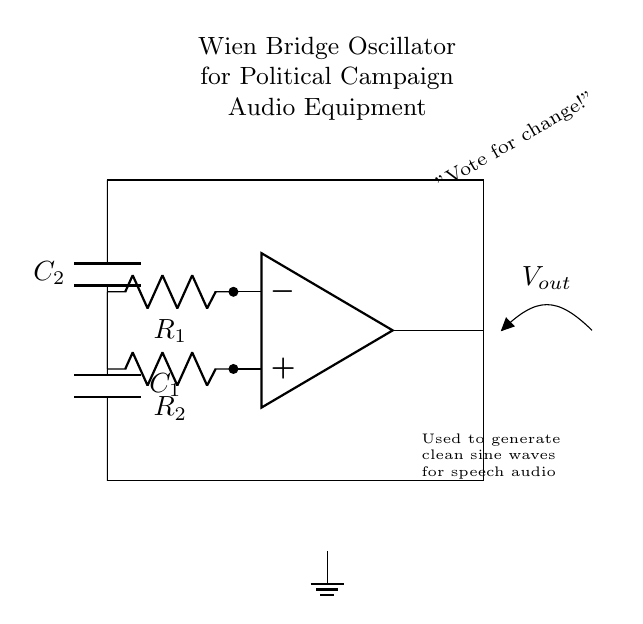What is the role of the op-amp in this circuit? The op-amp acts as a signal amplifier to produce a stable sine wave output by controlling the feedback from the resistors and capacitors.
Answer: Signal amplifier How many resistors are present in the circuit? The circuit includes two resistors, labeled R1 and R2, as shown in the diagram.
Answer: Two What is the purpose of the capacitors in the oscillator circuit? The capacitors (C1 and C2) are used for timing and frequency determination in the oscillator to create oscillations at a desired frequency.
Answer: Timing and frequency Which components are connected to the output of the op-amp? The output of the op-amp connects to both capacitors C1 and C2, indicating it feeds the generated signal to them for shaping the final output.
Answer: C1 and C2 What type of waves does this oscillator intend to generate? The Wiener bridge oscillator is designed to generate clean sine waves essential for audio applications in campaign events.
Answer: Sine waves How do the resistors and capacitors affect the oscillation frequency? The values of R1, R2, C1, and C2 are critical as they determine the oscillation frequency through their RC time constant relationship, where frequency is inversely proportional to time constants formed by these components.
Answer: RC time constant 